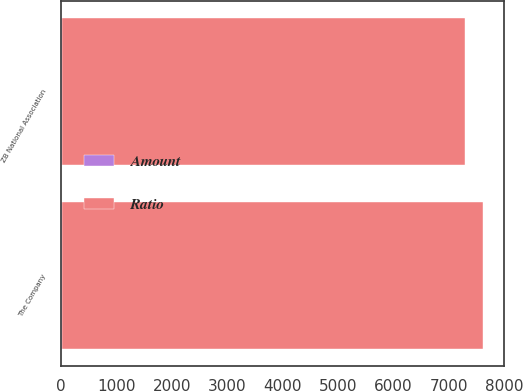Convert chart to OTSL. <chart><loc_0><loc_0><loc_500><loc_500><stacked_bar_chart><ecel><fcel>The Company<fcel>ZB National Association<nl><fcel>Ratio<fcel>7609<fcel>7278<nl><fcel>Amount<fcel>15.2<fcel>14.6<nl></chart> 